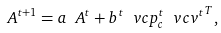<formula> <loc_0><loc_0><loc_500><loc_500>\ A ^ { t + 1 } = a \ A ^ { t } + b ^ { t } \ v c { p } _ { c } ^ { t } { \ v c { v } ^ { t } } ^ { T } ,</formula> 